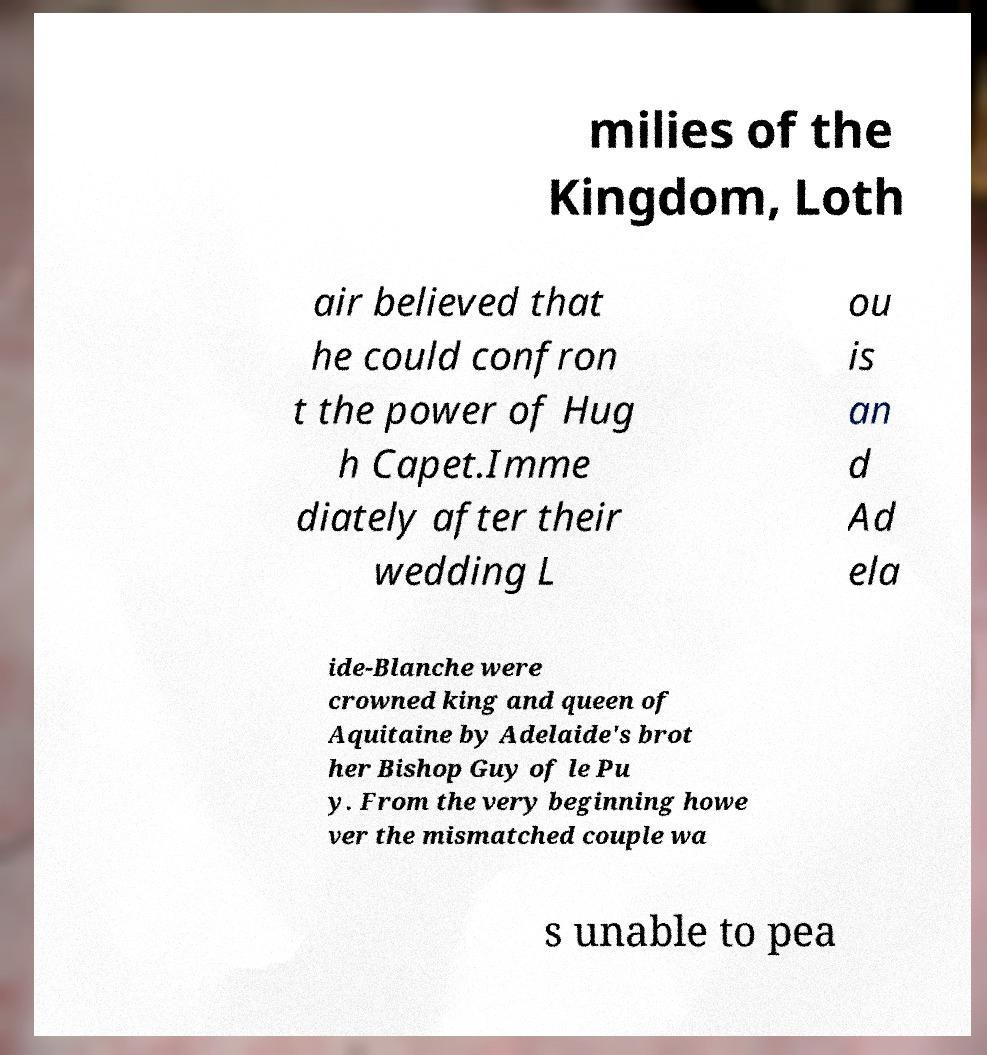There's text embedded in this image that I need extracted. Can you transcribe it verbatim? milies of the Kingdom, Loth air believed that he could confron t the power of Hug h Capet.Imme diately after their wedding L ou is an d Ad ela ide-Blanche were crowned king and queen of Aquitaine by Adelaide's brot her Bishop Guy of le Pu y. From the very beginning howe ver the mismatched couple wa s unable to pea 